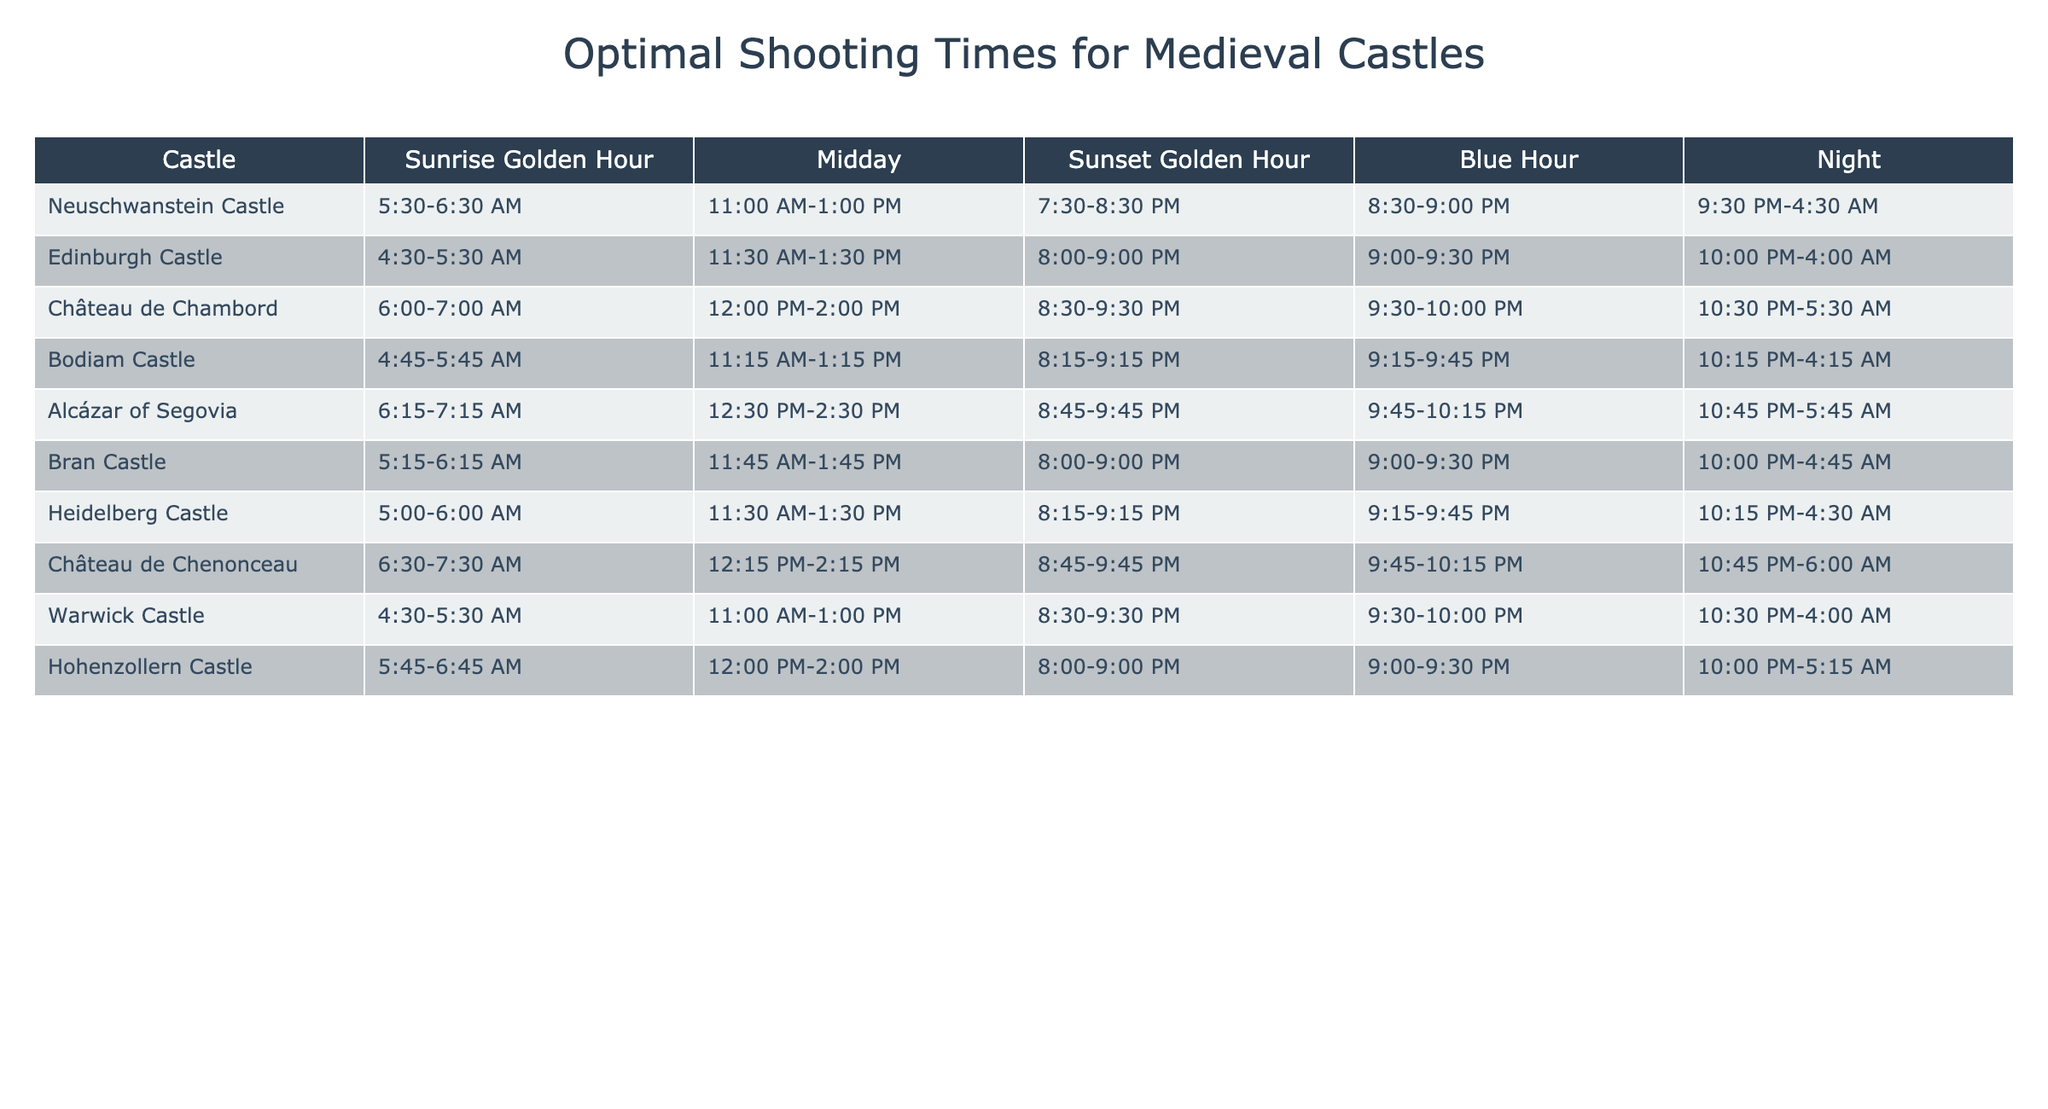What is the sunset golden hour time for Neuschwanstein Castle? According to the table, the sunset golden hour for Neuschwanstein Castle is from 7:30 PM to 8:30 PM.
Answer: 7:30 PM - 8:30 PM Which castle has the earliest sunrise golden hour? The table shows that Edinburgh Castle has the earliest sunrise golden hour, which is from 4:30 AM to 5:30 AM.
Answer: Edinburgh Castle What is the common range for the midday shooting time across all castles? By inspecting the midday shooting times for all castles, they conventionally range between 11:00 AM to 2:30 PM. The most frequent range is from 11:00 AM to 1:30 PM.
Answer: 11:00 AM - 2:30 PM Is the blue hour for Bran Castle the same as for Château de Chenonceau? The blue hour for Bran Castle is from 9:00 PM to 9:30 PM, while for Château de Chenonceau, it is from 9:45 PM to 10:15 PM. Therefore, they are not the same.
Answer: No Which castle has the longest shooting time available during the night? Analyzing the night shooting times, Château de Chambord has the longest duration stretching from 10:30 PM to 5:30 AM, totaling 7 hours.
Answer: Château de Chambord What is the difference in the sunset golden hour times between Hohenzollern Castle and Warwick Castle? Hohenzollern Castle has its sunset golden hour from 8:00 PM to 9:00 PM, while Warwick Castle's sunset golden hour is from 8:30 PM to 9:30 PM. The difference is 30 minutes, as Hohenzollern starts 30 minutes earlier.
Answer: 30 minutes Which castles have their midday shooting times overlapping? By checking the midday times, both Heidelberg Castle and Edinburgh Castle share the same midday slot from 11:30 AM to 1:30 PM, indicating an overlap.
Answer: Heidelberg and Edinburgh Castles Calculate the average starting time of the sunrise golden hour for all the castles. The sunrise golden hour starting times are: 5:30, 4:30, 6:00, 4:45, 6:15, 5:15, 5:00, 6:30, and 4:30. Converting these into minutes since midnight, the average is found by summing them (330 + 270 + 360 + 285 + 375 + 315 + 300 + 390 + 270) = 3295 minutes. There are 9 castles, therefore the average start time is 3295/9 = 366.11 minutes, totaling about 6:06 AM.
Answer: 6:06 AM Which castle offers the latest time for night photography? Analyzing night photography times, the latest time is for the Château de Chenonceau, where night shooting lasts until 6:00 AM.
Answer: Château de Chenonceau What is the latest sunset golden hour time among all the castles? From the table, the latest sunset golden hour time is 9:45 PM from two castles: Alcázar of Segovia and Château de Chambord.
Answer: 9:45 PM 